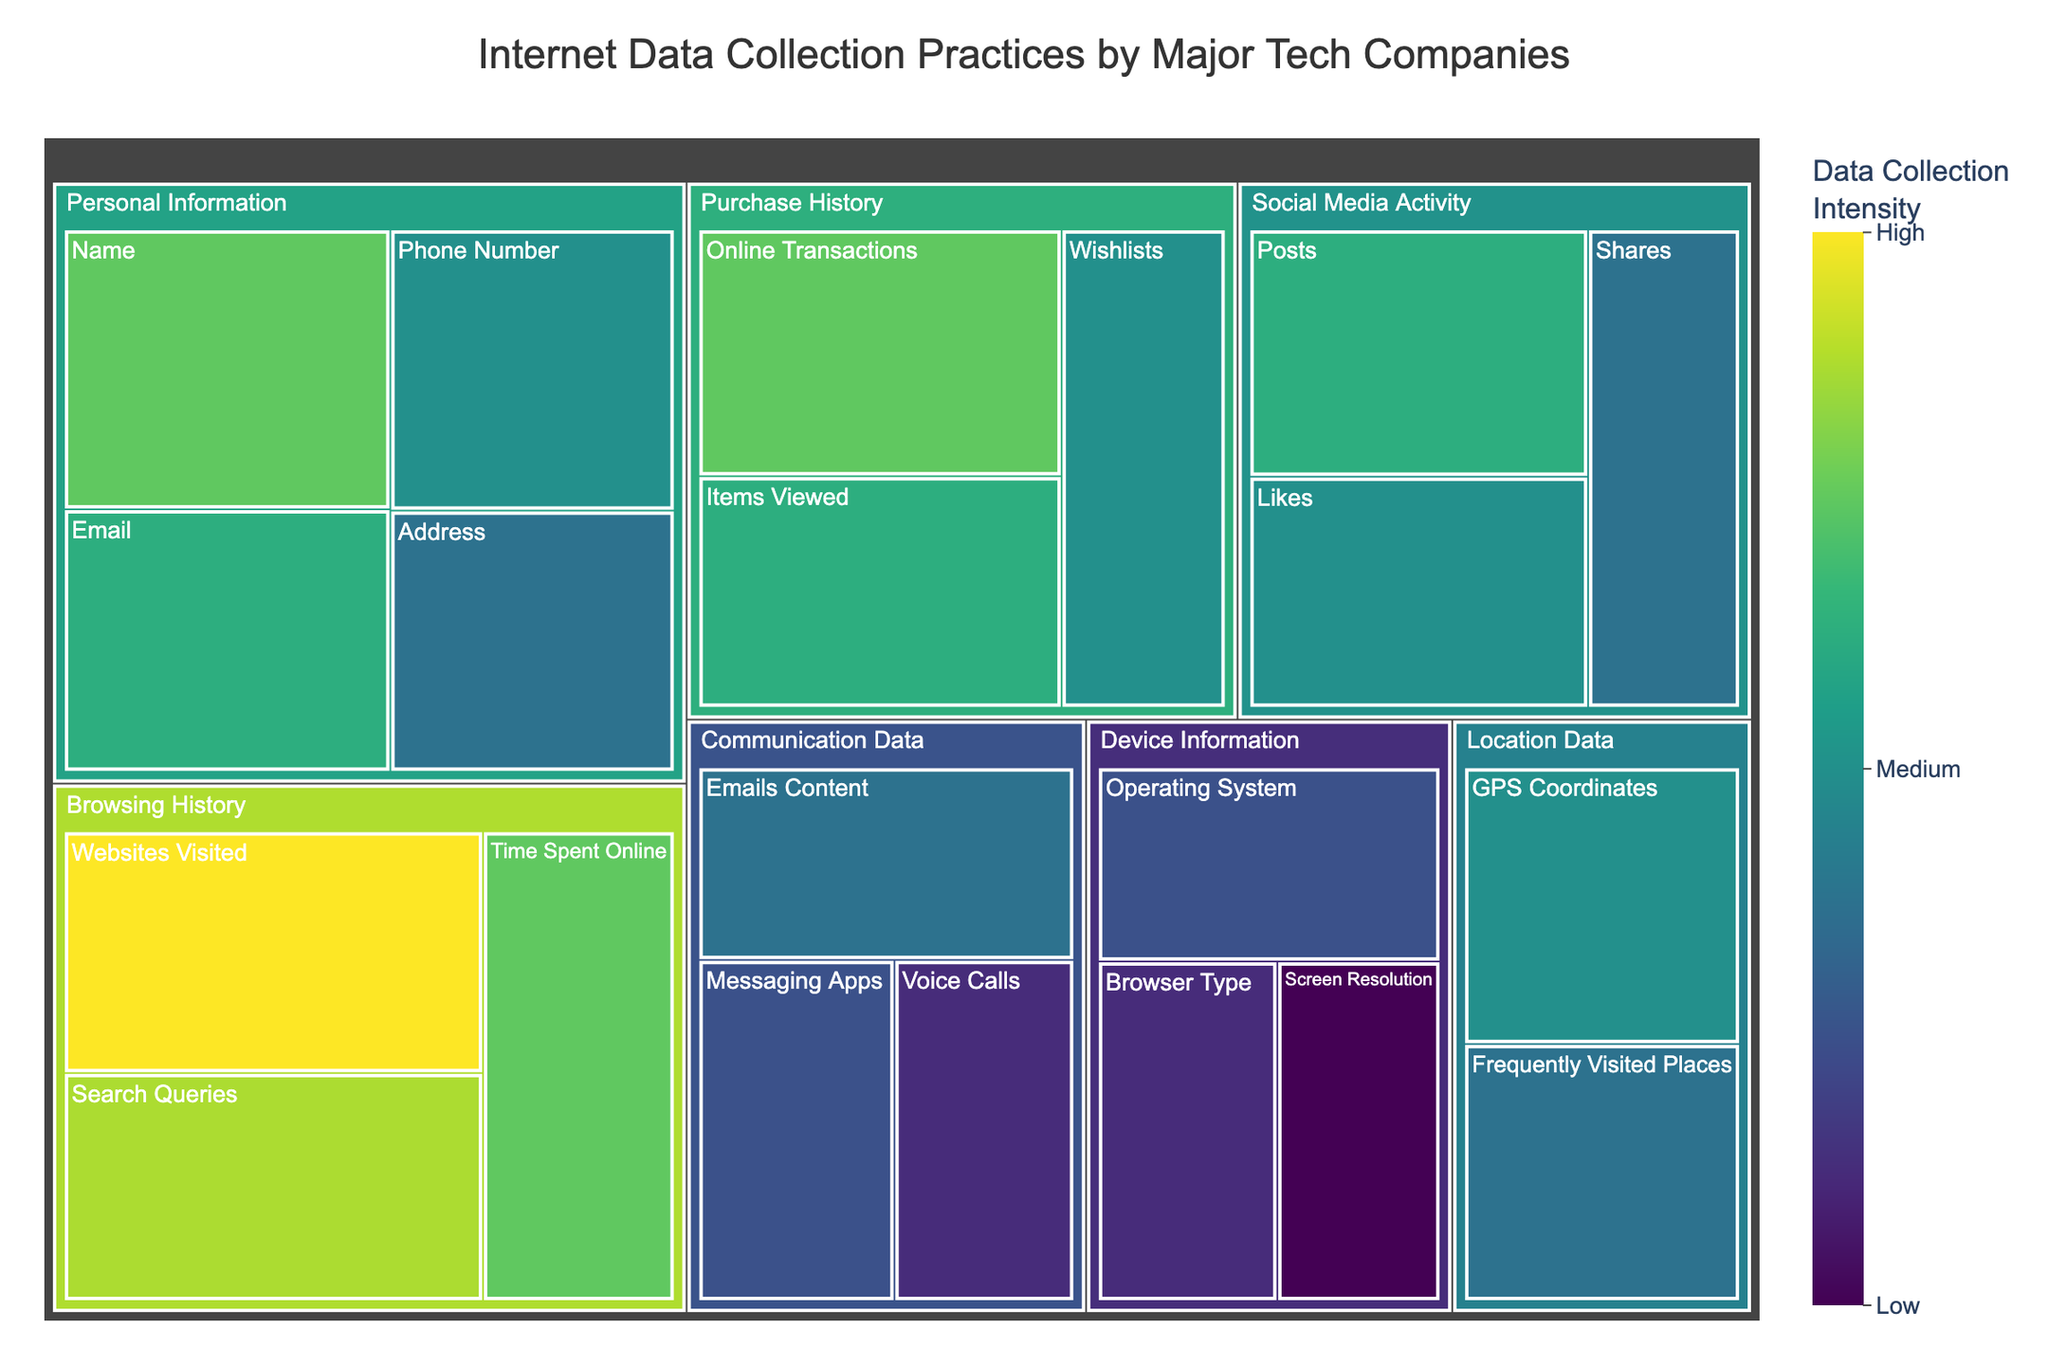What is the title of the treemap? The title of the treemap is typically displayed prominently at the top of the figure. In this case, it is "Internet Data Collection Practices by Major Tech Companies".
Answer: Internet Data Collection Practices by Major Tech Companies Which personal information category has the highest value, and what is it? Within the "Personal Information" category, the subcategory with the highest value is "Name". This can be deduced by observing the sizes and values displayed in the treemap's tiles.
Answer: Name, 80 How does the value for "Search Queries" compare to the value for "Websites Visited"? The value for "Search Queries" is 85, whereas the value for "Websites Visited" is 90. This comparison shows that "Websites Visited" has a higher value than "Search Queries".
Answer: "Websites Visited" has a higher value than "Search Queries" What is the combined value of the data points in the "Device Information" category? The subcategories under "Device Information" are 'Operating System' (60), 'Browser Type' (55), and 'Screen Resolution' (50). Adding these together: 60 + 55 + 50 = 165
Answer: 165 Which category has the most diverse set of data points in terms of value range? The "Browsing History" category contains values ranging from 80 to 90. This range of 10 points indicates a diverse set of data points compared to other categories.
Answer: Browsing History What value is assigned to "Frequently Visited Places" and how does it compare to "GPS Coordinates"? "Frequently Visited Places" has a value of 65, whereas "GPS Coordinates" has a value of 70. "GPS Coordinates" has a higher value.
Answer: 65, "GPS Coordinates" is higher What is the average value of the "Social Media Activity" subcategories? The subcategories under "Social Media Activity" are 'Posts' (75), 'Likes' (70), and 'Shares' (65). To find the average: (75 + 70 + 65) / 3 = 70
Answer: 70 Among "Purchase History" data, which subcategory has the lowest value? The subcategories under "Purchase History" include 'Online Transactions' (80), 'Items Viewed' (75), and 'Wishlists' (70). The lowest of these is 'Wishlists'.
Answer: Wishlists, 70 